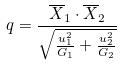Convert formula to latex. <formula><loc_0><loc_0><loc_500><loc_500>q = \frac { \overline { X } _ { 1 } \cdot \overline { X } _ { 2 } } { \sqrt { \frac { u _ { 1 } ^ { 2 } } { G _ { 1 } } + \frac { u _ { 2 } ^ { 2 } } { G _ { 2 } } } }</formula> 